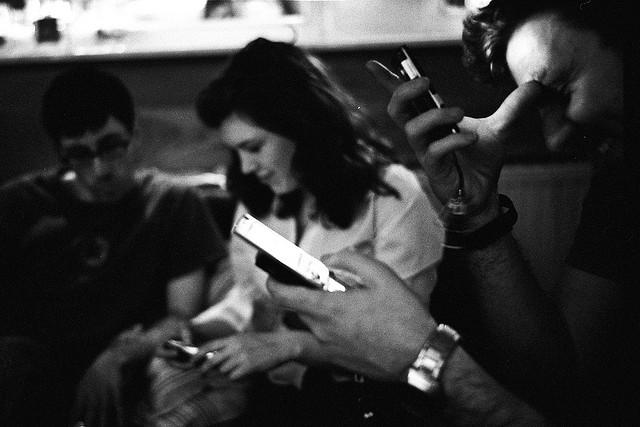What color is the color?
Answer briefly. Black and white. Who many women are?
Short answer required. 1. What is present?
Short answer required. People. 